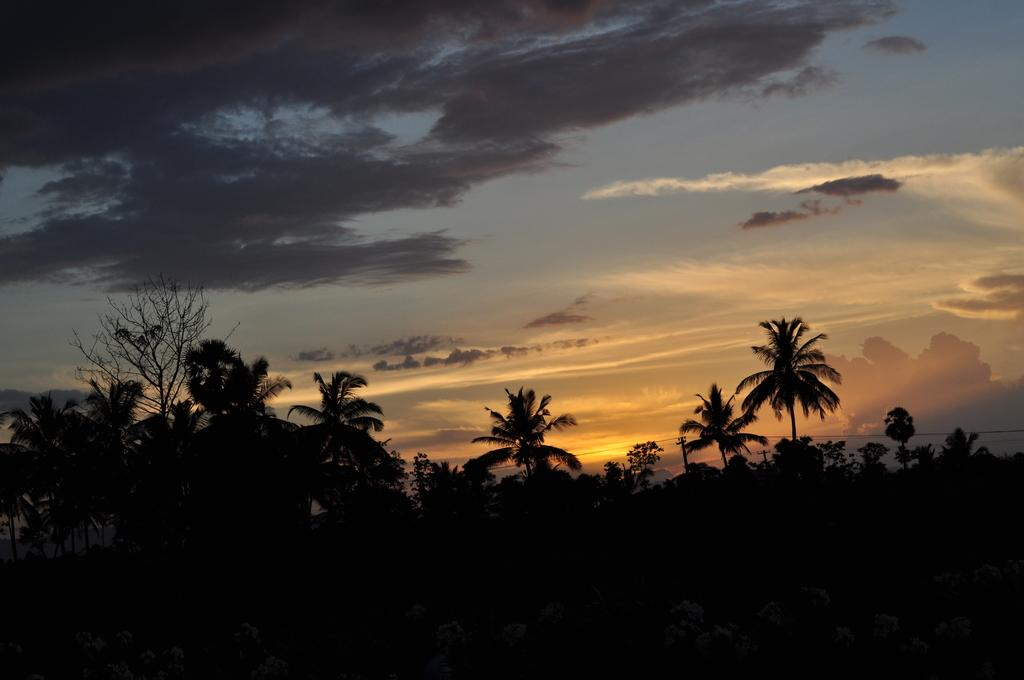Where was the image taken? The image was clicked outside. What can be seen in the middle of the image? There are trees in the middle of the image. What is visible at the top of the image? There is sky visible at the top of the image. What can be observed in the sky? There are clouds in the sky. What account number is written on the tree in the image? There is no account number present on the tree in the image. 